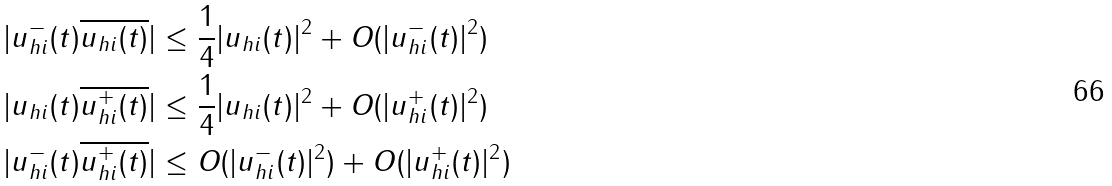Convert formula to latex. <formula><loc_0><loc_0><loc_500><loc_500>| u ^ { - } _ { h i } ( t ) \overline { u _ { h i } ( t ) } | & \leq \frac { 1 } { 4 } | u _ { h i } ( t ) | ^ { 2 } + O ( | u ^ { - } _ { h i } ( t ) | ^ { 2 } ) \\ | u _ { h i } ( t ) \overline { u ^ { + } _ { h i } ( t ) } | & \leq \frac { 1 } { 4 } | u _ { h i } ( t ) | ^ { 2 } + O ( | u ^ { + } _ { h i } ( t ) | ^ { 2 } ) \\ | u ^ { - } _ { h i } ( t ) \overline { u ^ { + } _ { h i } ( t ) } | & \leq O ( | u ^ { - } _ { h i } ( t ) | ^ { 2 } ) + O ( | u ^ { + } _ { h i } ( t ) | ^ { 2 } )</formula> 